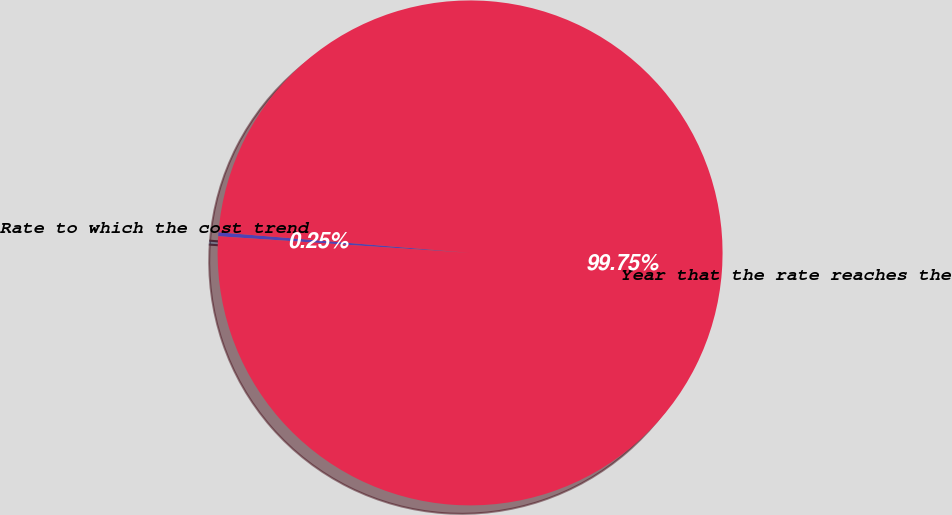<chart> <loc_0><loc_0><loc_500><loc_500><pie_chart><fcel>Rate to which the cost trend<fcel>Year that the rate reaches the<nl><fcel>0.25%<fcel>99.75%<nl></chart> 